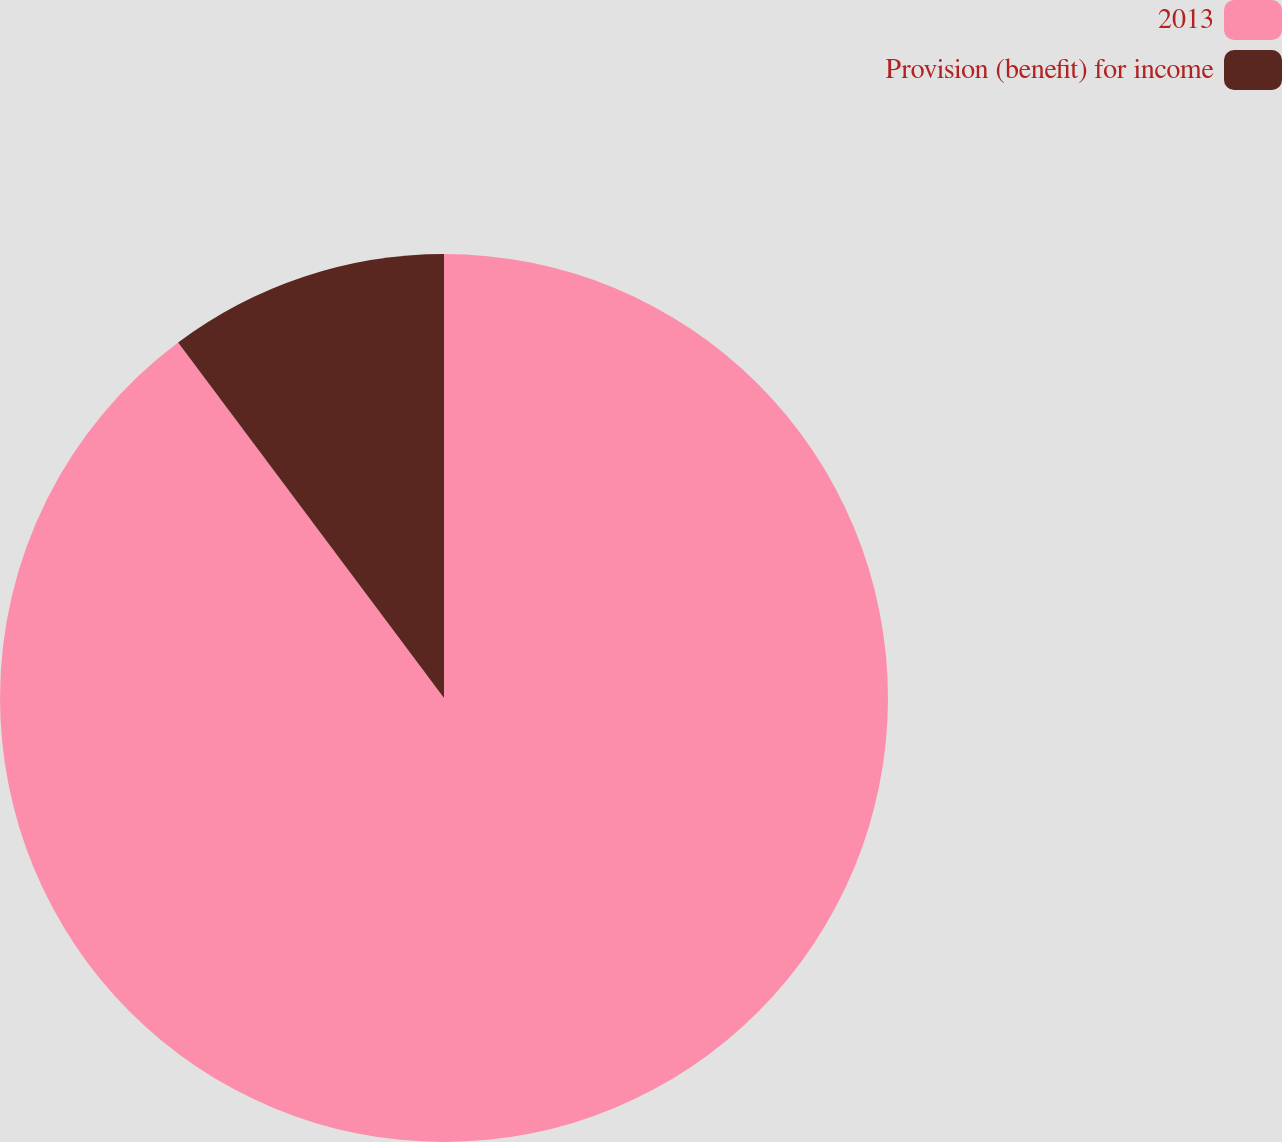<chart> <loc_0><loc_0><loc_500><loc_500><pie_chart><fcel>2013<fcel>Provision (benefit) for income<nl><fcel>89.78%<fcel>10.22%<nl></chart> 